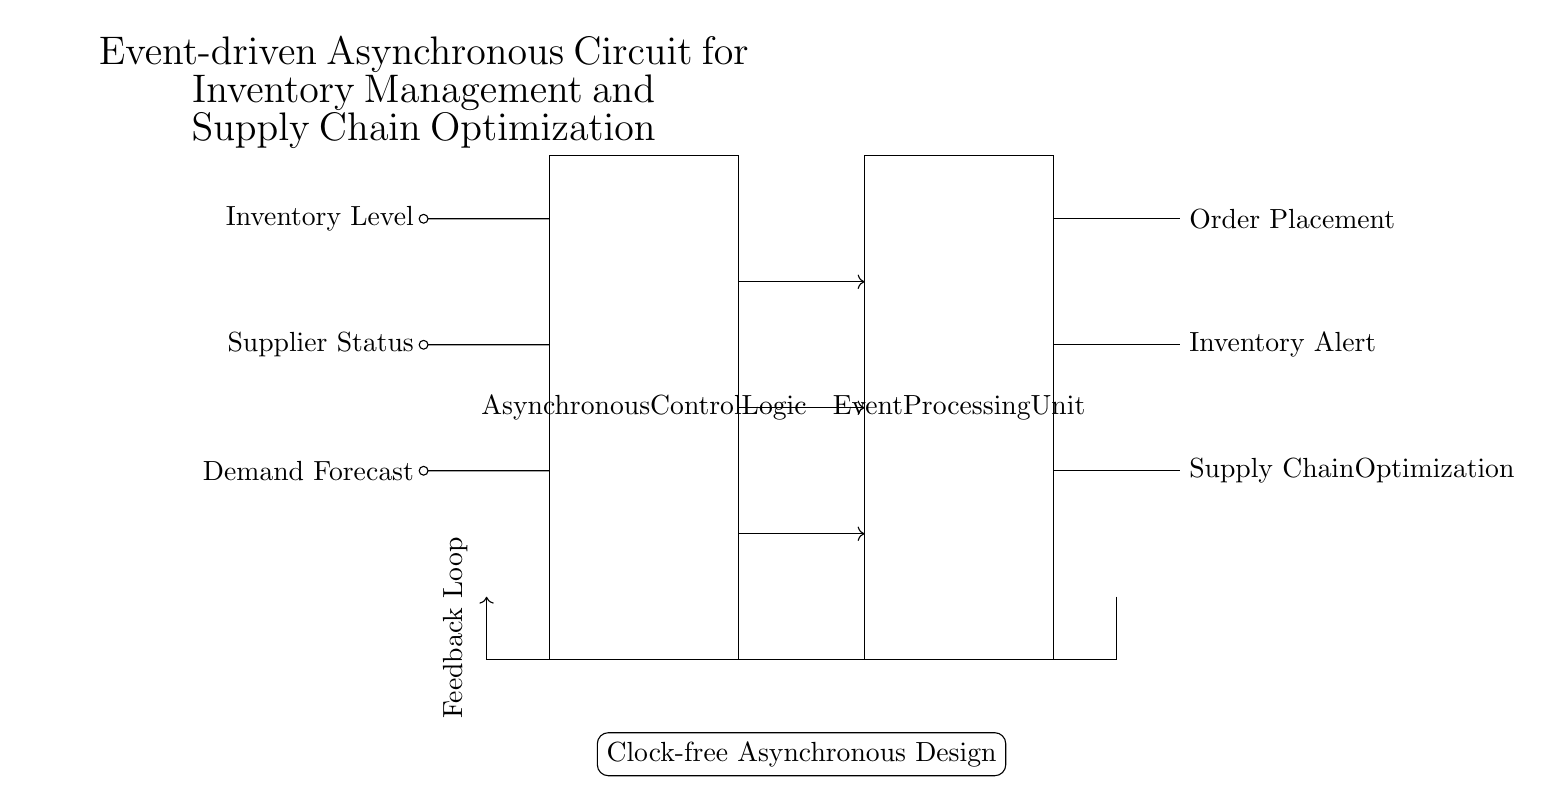What are the input signals for the circuit? The circuit has three input signals labeled: Inventory Level, Supplier Status, and Demand Forecast. These inputs are critical for the operation of the asynchronous control logic.
Answer: Inventory Level, Supplier Status, Demand Forecast What is the purpose of the Event Processing Unit? The Event Processing Unit receives outputs from the asynchronous control logic and is responsible for handling event-driven tasks such as Order Placement, Inventory Alerts, and Supply Chain Optimization.
Answer: Event Handling What is the feedback loop in this circuit indicating? The feedback loop suggests that the circuit design accommodates return signals that help refine the control logic based on the outcomes of the processing, enhancing decision-making.
Answer: Refinement What is the significance of "Clock-free Asynchronous Design"? Clock-free designs operate without a global clock signal, allowing components to respond to changes more flexibly and potentially faster, reducing delay caused by synchronization.
Answer: Flexibility How many output signals does the circuit have? The output signals include Order Placement, Inventory Alert, and Supply Chain Optimization, totaling three distinct outputs derived from processing the input signals.
Answer: Three What type of circuit is this? The circuit is an asynchronous circuit, which is specifically designed to operate without synchronized clock signals, using event-driven logic instead.
Answer: Asynchronous What does the rectangle labeled "Asynchronous Control Logic" represent? This rectangle signifies a component of the circuit that processes incoming signals to determine appropriate actions based on the current inventory status, supplier conditions, and demand forecasts.
Answer: Control Logic 